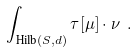Convert formula to latex. <formula><loc_0><loc_0><loc_500><loc_500>\int _ { { \text {Hilb} } ( S , d ) } \tau [ \mu ] \cdot \nu \ .</formula> 